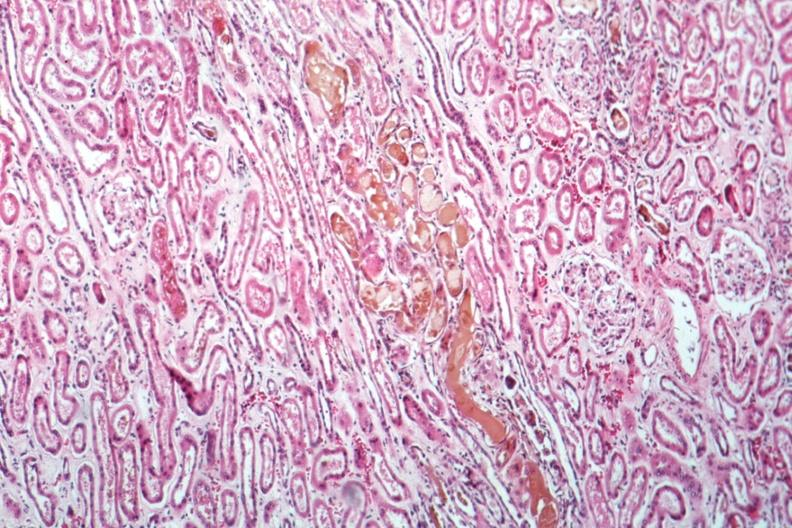does this image show bile nephrosis very good example?
Answer the question using a single word or phrase. Yes 